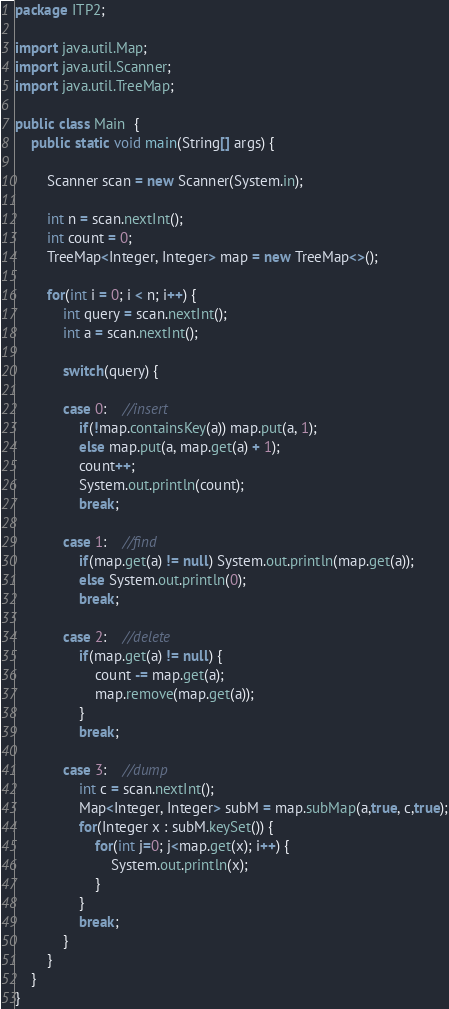Convert code to text. <code><loc_0><loc_0><loc_500><loc_500><_Java_>package ITP2;

import java.util.Map;
import java.util.Scanner;
import java.util.TreeMap;

public class Main  {
	public static void main(String[] args) {

		Scanner scan = new Scanner(System.in);

		int n = scan.nextInt();
		int count = 0;
		TreeMap<Integer, Integer> map = new TreeMap<>();

		for(int i = 0; i < n; i++) {
			int query = scan.nextInt();
			int a = scan.nextInt();

			switch(query) {

			case 0:	//insert
				if(!map.containsKey(a)) map.put(a, 1);
				else map.put(a, map.get(a) + 1);
				count++;
				System.out.println(count);
				break;

			case 1:	//find
				if(map.get(a) != null) System.out.println(map.get(a));
				else System.out.println(0);
				break;

			case 2:	//delete
				if(map.get(a) != null) {
					count -= map.get(a);
					map.remove(map.get(a));
				}
				break;

			case 3:	//dump
				int c = scan.nextInt();
				Map<Integer, Integer> subM = map.subMap(a,true, c,true);
				for(Integer x : subM.keySet()) {
					for(int j=0; j<map.get(x); i++) {
						System.out.println(x);
					}
				}
				break;
			}
		}
	}
}

</code> 